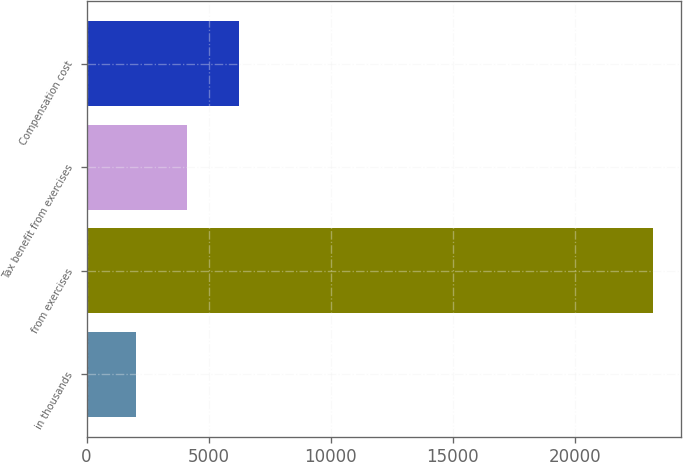Convert chart to OTSL. <chart><loc_0><loc_0><loc_500><loc_500><bar_chart><fcel>in thousands<fcel>from exercises<fcel>Tax benefit from exercises<fcel>Compensation cost<nl><fcel>2014<fcel>23199<fcel>4132.5<fcel>6251<nl></chart> 